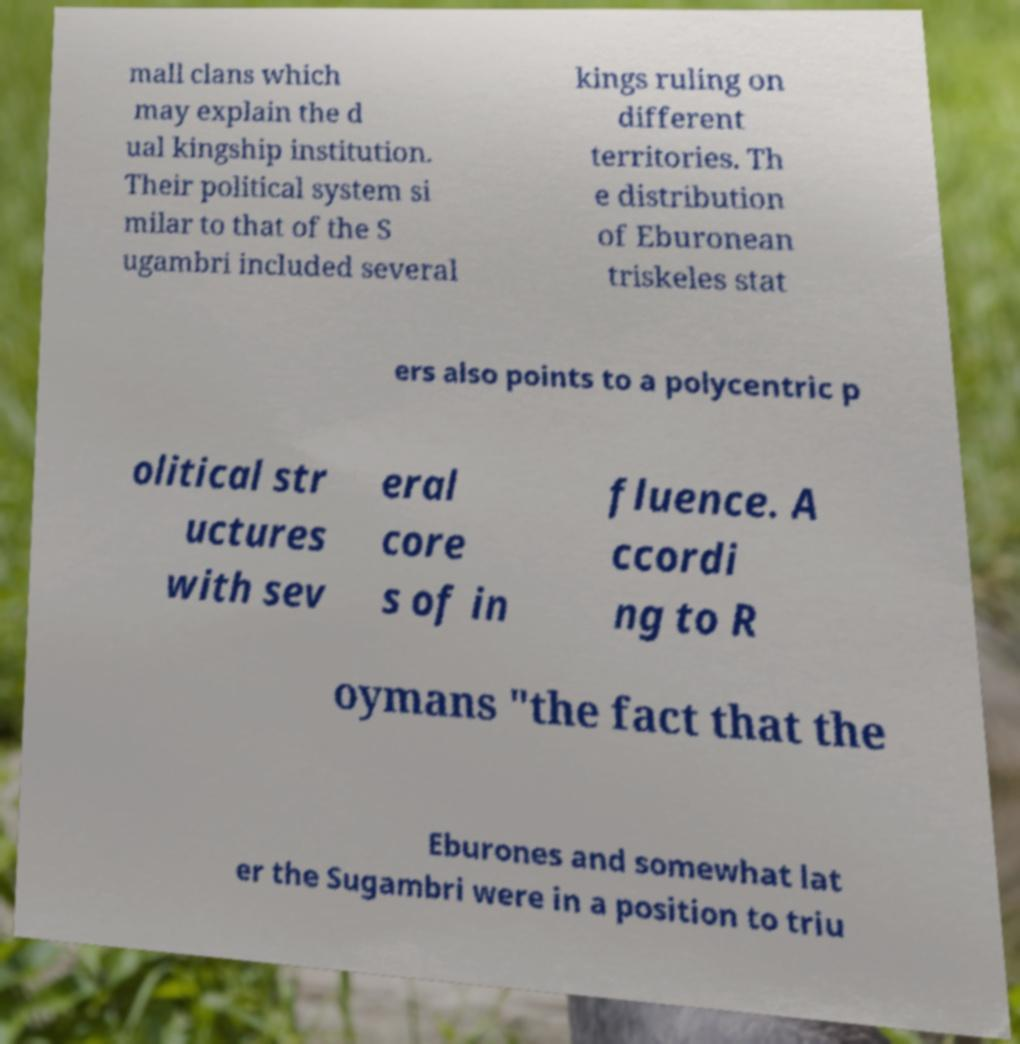Can you read and provide the text displayed in the image?This photo seems to have some interesting text. Can you extract and type it out for me? mall clans which may explain the d ual kingship institution. Their political system si milar to that of the S ugambri included several kings ruling on different territories. Th e distribution of Eburonean triskeles stat ers also points to a polycentric p olitical str uctures with sev eral core s of in fluence. A ccordi ng to R oymans "the fact that the Eburones and somewhat lat er the Sugambri were in a position to triu 